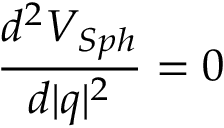<formula> <loc_0><loc_0><loc_500><loc_500>\frac { d ^ { 2 } V _ { S p h } } { d | q | ^ { 2 } } = 0</formula> 